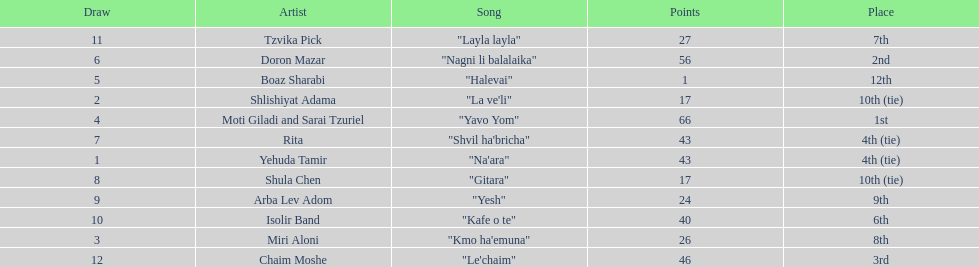What song earned the most points? "Yavo Yom". 